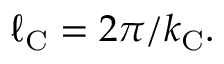<formula> <loc_0><loc_0><loc_500><loc_500>\ell _ { C } = 2 \pi / k _ { C } .</formula> 